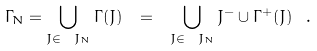<formula> <loc_0><loc_0><loc_500><loc_500>\Gamma _ { N } = \bigcup _ { J \in \ J _ { N } } \Gamma ( J ) \ = \ \bigcup _ { J \in \ J _ { N } } J ^ { - } \cup \Gamma ^ { + } ( J ) \ .</formula> 